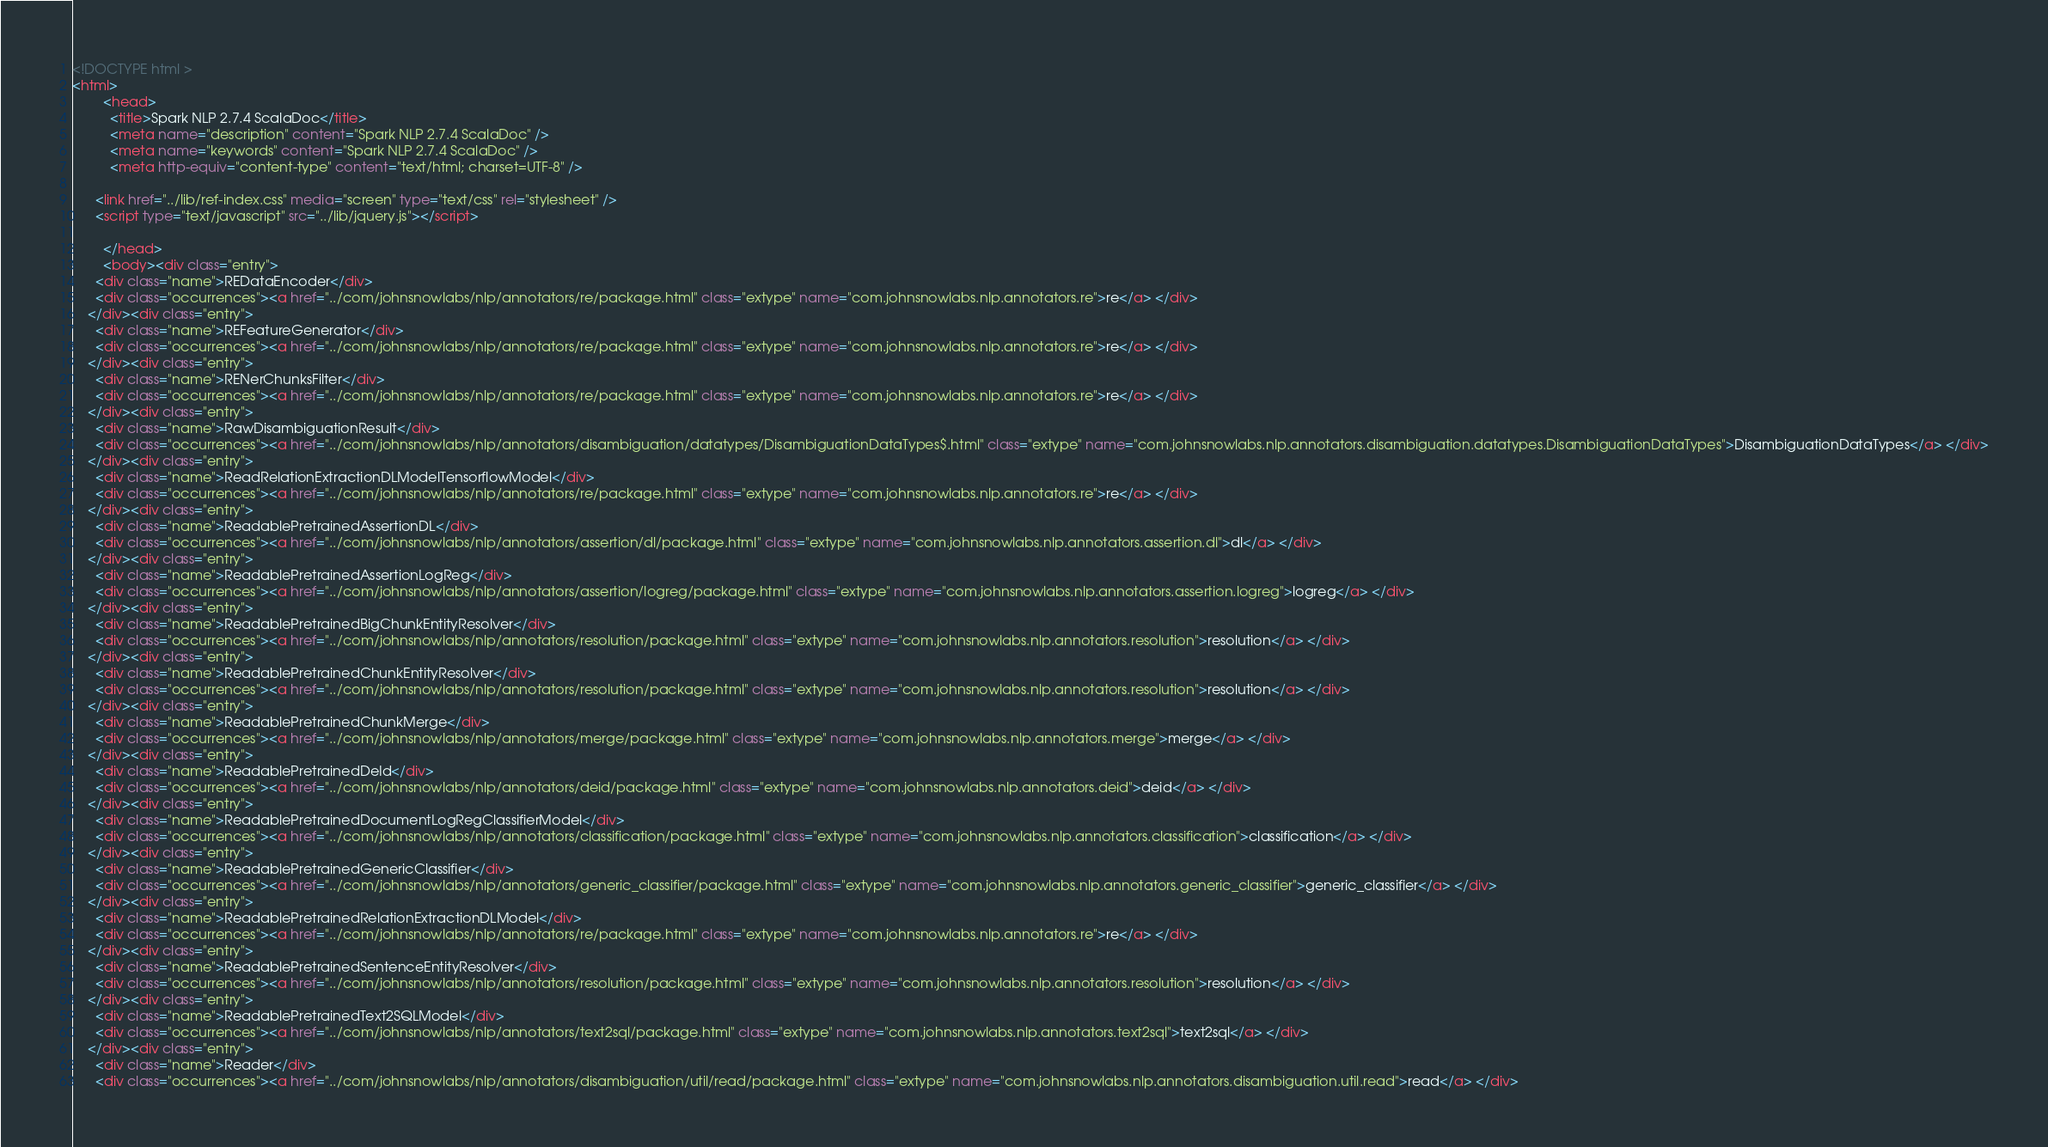Convert code to text. <code><loc_0><loc_0><loc_500><loc_500><_HTML_><!DOCTYPE html >
<html>
        <head>
          <title>Spark NLP 2.7.4 ScalaDoc</title>
          <meta name="description" content="Spark NLP 2.7.4 ScalaDoc" />
          <meta name="keywords" content="Spark NLP 2.7.4 ScalaDoc" />
          <meta http-equiv="content-type" content="text/html; charset=UTF-8" />
          
      <link href="../lib/ref-index.css" media="screen" type="text/css" rel="stylesheet" />
      <script type="text/javascript" src="../lib/jquery.js"></script>
    
        </head>
        <body><div class="entry">
      <div class="name">REDataEncoder</div>
      <div class="occurrences"><a href="../com/johnsnowlabs/nlp/annotators/re/package.html" class="extype" name="com.johnsnowlabs.nlp.annotators.re">re</a> </div>
    </div><div class="entry">
      <div class="name">REFeatureGenerator</div>
      <div class="occurrences"><a href="../com/johnsnowlabs/nlp/annotators/re/package.html" class="extype" name="com.johnsnowlabs.nlp.annotators.re">re</a> </div>
    </div><div class="entry">
      <div class="name">RENerChunksFilter</div>
      <div class="occurrences"><a href="../com/johnsnowlabs/nlp/annotators/re/package.html" class="extype" name="com.johnsnowlabs.nlp.annotators.re">re</a> </div>
    </div><div class="entry">
      <div class="name">RawDisambiguationResult</div>
      <div class="occurrences"><a href="../com/johnsnowlabs/nlp/annotators/disambiguation/datatypes/DisambiguationDataTypes$.html" class="extype" name="com.johnsnowlabs.nlp.annotators.disambiguation.datatypes.DisambiguationDataTypes">DisambiguationDataTypes</a> </div>
    </div><div class="entry">
      <div class="name">ReadRelationExtractionDLModelTensorflowModel</div>
      <div class="occurrences"><a href="../com/johnsnowlabs/nlp/annotators/re/package.html" class="extype" name="com.johnsnowlabs.nlp.annotators.re">re</a> </div>
    </div><div class="entry">
      <div class="name">ReadablePretrainedAssertionDL</div>
      <div class="occurrences"><a href="../com/johnsnowlabs/nlp/annotators/assertion/dl/package.html" class="extype" name="com.johnsnowlabs.nlp.annotators.assertion.dl">dl</a> </div>
    </div><div class="entry">
      <div class="name">ReadablePretrainedAssertionLogReg</div>
      <div class="occurrences"><a href="../com/johnsnowlabs/nlp/annotators/assertion/logreg/package.html" class="extype" name="com.johnsnowlabs.nlp.annotators.assertion.logreg">logreg</a> </div>
    </div><div class="entry">
      <div class="name">ReadablePretrainedBigChunkEntityResolver</div>
      <div class="occurrences"><a href="../com/johnsnowlabs/nlp/annotators/resolution/package.html" class="extype" name="com.johnsnowlabs.nlp.annotators.resolution">resolution</a> </div>
    </div><div class="entry">
      <div class="name">ReadablePretrainedChunkEntityResolver</div>
      <div class="occurrences"><a href="../com/johnsnowlabs/nlp/annotators/resolution/package.html" class="extype" name="com.johnsnowlabs.nlp.annotators.resolution">resolution</a> </div>
    </div><div class="entry">
      <div class="name">ReadablePretrainedChunkMerge</div>
      <div class="occurrences"><a href="../com/johnsnowlabs/nlp/annotators/merge/package.html" class="extype" name="com.johnsnowlabs.nlp.annotators.merge">merge</a> </div>
    </div><div class="entry">
      <div class="name">ReadablePretrainedDeId</div>
      <div class="occurrences"><a href="../com/johnsnowlabs/nlp/annotators/deid/package.html" class="extype" name="com.johnsnowlabs.nlp.annotators.deid">deid</a> </div>
    </div><div class="entry">
      <div class="name">ReadablePretrainedDocumentLogRegClassifierModel</div>
      <div class="occurrences"><a href="../com/johnsnowlabs/nlp/annotators/classification/package.html" class="extype" name="com.johnsnowlabs.nlp.annotators.classification">classification</a> </div>
    </div><div class="entry">
      <div class="name">ReadablePretrainedGenericClassifier</div>
      <div class="occurrences"><a href="../com/johnsnowlabs/nlp/annotators/generic_classifier/package.html" class="extype" name="com.johnsnowlabs.nlp.annotators.generic_classifier">generic_classifier</a> </div>
    </div><div class="entry">
      <div class="name">ReadablePretrainedRelationExtractionDLModel</div>
      <div class="occurrences"><a href="../com/johnsnowlabs/nlp/annotators/re/package.html" class="extype" name="com.johnsnowlabs.nlp.annotators.re">re</a> </div>
    </div><div class="entry">
      <div class="name">ReadablePretrainedSentenceEntityResolver</div>
      <div class="occurrences"><a href="../com/johnsnowlabs/nlp/annotators/resolution/package.html" class="extype" name="com.johnsnowlabs.nlp.annotators.resolution">resolution</a> </div>
    </div><div class="entry">
      <div class="name">ReadablePretrainedText2SQLModel</div>
      <div class="occurrences"><a href="../com/johnsnowlabs/nlp/annotators/text2sql/package.html" class="extype" name="com.johnsnowlabs.nlp.annotators.text2sql">text2sql</a> </div>
    </div><div class="entry">
      <div class="name">Reader</div>
      <div class="occurrences"><a href="../com/johnsnowlabs/nlp/annotators/disambiguation/util/read/package.html" class="extype" name="com.johnsnowlabs.nlp.annotators.disambiguation.util.read">read</a> </div></code> 